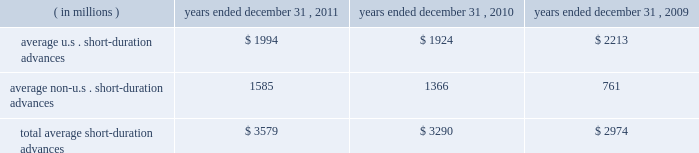Average securities purchased under resale agreements increased to $ 4.69 billion for the year ended december 31 , 2011 from $ 2.96 billion for the year ended december 31 , 2010 .
Average trading account assets increased to $ 2.01 billion for the year ended december 31 , 2011 from $ 376 million for 2010 .
Averages benefited largely from an increase in client demand associated with our trading activities .
In connection with these activities , we traded in highly liquid fixed-income securities as principal with our custody clients and other third- parties that trade in these securities .
Our average investment securities portfolio increased to $ 103.08 billion for the year ended december 31 , 2011 from $ 96.12 billion for 2010 .
The increase was generally the result of ongoing purchases of securities , partly offset by maturities and sales .
In december 2010 , we repositioned our portfolio by selling approximately $ 11 billion of mortgage- and asset-backed securities and re-investing approximately $ 7 billion of the proceeds , primarily in agency mortgage-backed securities .
The repositioning was undertaken to enhance our regulatory capital ratios under evolving regulatory capital standards , increase our balance sheet flexibility in deploying our capital , and reduce our exposure to certain asset classes .
During 2011 , we purchased $ 54 billion of highly rated u.s .
Treasury securities , federal agency mortgage-backed securities and u.s .
And non-u.s .
Asset-backed securities .
As of december 31 , 2011 , securities rated 201caaa 201d and 201caa 201d comprised approximately 89% ( 89 % ) of our portfolio , compared to 90% ( 90 % ) rated 201caaa 201d and 201caa 201d as of december 31 , 2010 .
Loans and leases averaged $ 12.18 billion for the year ended december 31 , 2011 , compared to $ 12.09 billion for 2010 .
The increases primarily resulted from higher client demand for short-duration liquidity , offset in part by a decrease in leases and the purchased receivables added in connection with the conduit consolidation , mainly from maturities and pay-downs .
For 2011 and 2010 , approximately 29% ( 29 % ) and 27% ( 27 % ) , respectively , of our average loan and lease portfolio was composed of short-duration advances that provided liquidity to clients in support of their investment activities related to securities settlement .
The table presents average u.s .
And non-u.s .
Short-duration advances for the years indicated: .
For the year ended december 31 , 2011 , the increase in average non-u.s .
Short-duration advances compared to the prior-year period was mainly due to activity associated with clients added in connection with the acquired intesa securities services business .
Average other interest-earning assets increased to $ 5.46 billion for the year ended december 31 , 2011 from $ 1.16 billion for 2010 .
The increase was primarily the result of higher levels of cash collateral provided in connection with our role as principal in certain securities borrowing activities .
Average interest-bearing deposits increased to $ 88.06 billion for the year ended december 31 , 2011 from $ 76.96 billion for 2010 .
The increase reflected client deposits added in connection with the may 2010 acquisition of the intesa securities services business , and higher levels of non-u.s .
Transaction accounts associated with new and existing business in assets under custody and administration .
Average other short-term borrowings declined to $ 5.13 billion for the year ended december 31 , 2011 from $ 13.59 billion for 2010 , as the higher levels of client deposits provided additional liquidity .
Average long-term debt increased to $ 8.97 billion for the year ended december 31 , 2011 from $ 8.68 billion for the same period in 2010 .
The increase primarily reflected the issuance of an aggregate of $ 2 billion of senior notes by us in march 2011 , partly offset by the maturities of $ 1 billion of senior notes in february 2011 and $ 1.45 billion of senior notes in september 2011 , both previously issued by state street bank under the fdic 2019s temporary liquidity guarantee program .
Additional information about our long-term debt is provided in note 9 to the consolidated financial statements included under item 8. .
What portion of the total short-term duration advances are u.s short-term advances? 
Computations: (1994 / 3579)
Answer: 0.55714. 